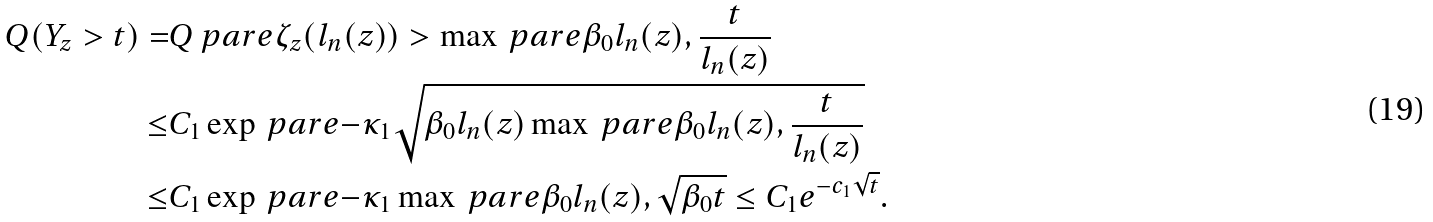<formula> <loc_0><loc_0><loc_500><loc_500>Q ( Y _ { z } > t ) = & Q \ p a r e { \zeta _ { z } ( l _ { n } ( z ) ) > \max \ p a r e { \beta _ { 0 } l _ { n } ( z ) , \frac { t } { l _ { n } ( z ) } } } \\ \leq & C _ { 1 } \exp \ p a r e { - \kappa _ { 1 } \sqrt { \beta _ { 0 } l _ { n } ( z ) \max \ p a r e { \beta _ { 0 } l _ { n } ( z ) , \frac { t } { l _ { n } ( z ) } } } } \\ \leq & C _ { 1 } \exp \ p a r e { - \kappa _ { 1 } \max \ p a r e { \beta _ { 0 } l _ { n } ( z ) , \sqrt { \beta _ { 0 } t } } } \leq C _ { 1 } e ^ { - c _ { 1 } \sqrt { t } } .</formula> 